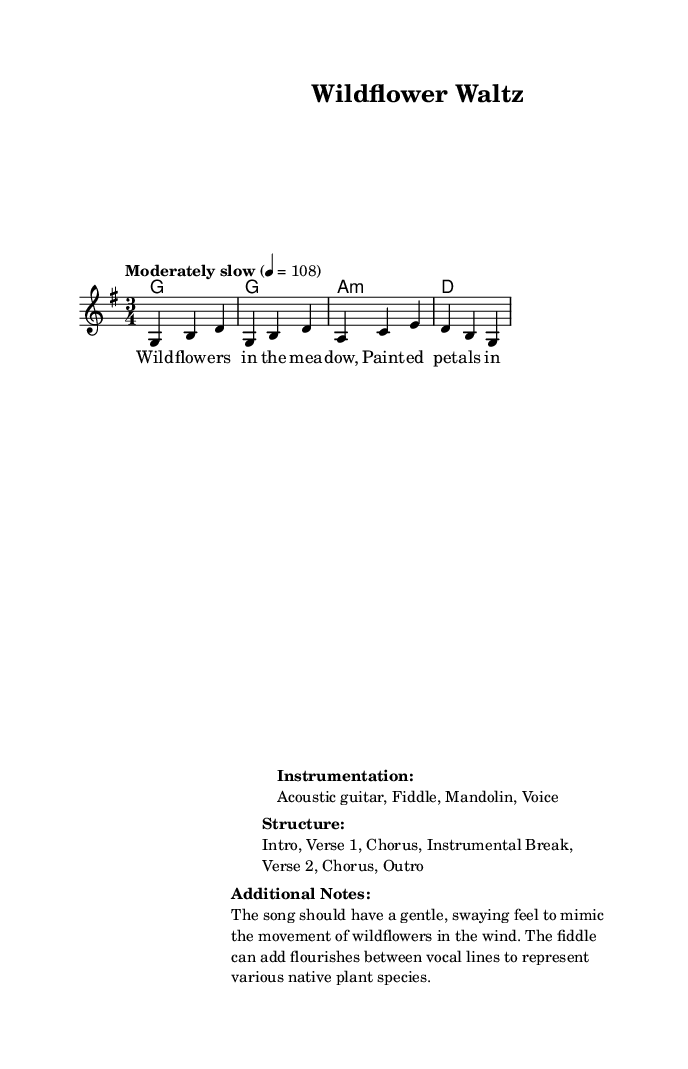What is the key signature of this music? The key signature is indicated by the "g" in the global section, which signifies that the piece is in G major, containing one sharp (F#).
Answer: G major What is the time signature of this music? The time signature is explicitly stated as "3/4" in the global section, indicating that each measure contains three beats, with each beat being a quarter note.
Answer: 3/4 What is the tempo marking for this piece? The tempo is given as "Moderately slow" with a metronome marking of 108 beats per minute in the global section, indicating the speed at which the music should be played.
Answer: Moderately slow How many verses does this song have? The structure outlined in the markup notes that the song includes an Intro, Verse 1, Chorus, Instrumental Break, Verse 2, Chorus, and an Outro, totaling two verses.
Answer: 2 What instruments are specified for this piece? The markup lists the instruments as Acoustic guitar, Fiddle, Mandolin, and Voice, specifying the instrumentation needed for the performance of this song.
Answer: Acoustic guitar, Fiddle, Mandolin, Voice What is the mood that the song aims to convey? The additional notes mention that the song should have a gentle, swaying feel to mimic the movement of wildflowers in the wind, highlighting an intention to evoke tranquility and nature's beauty.
Answer: Gentle, swaying feel 